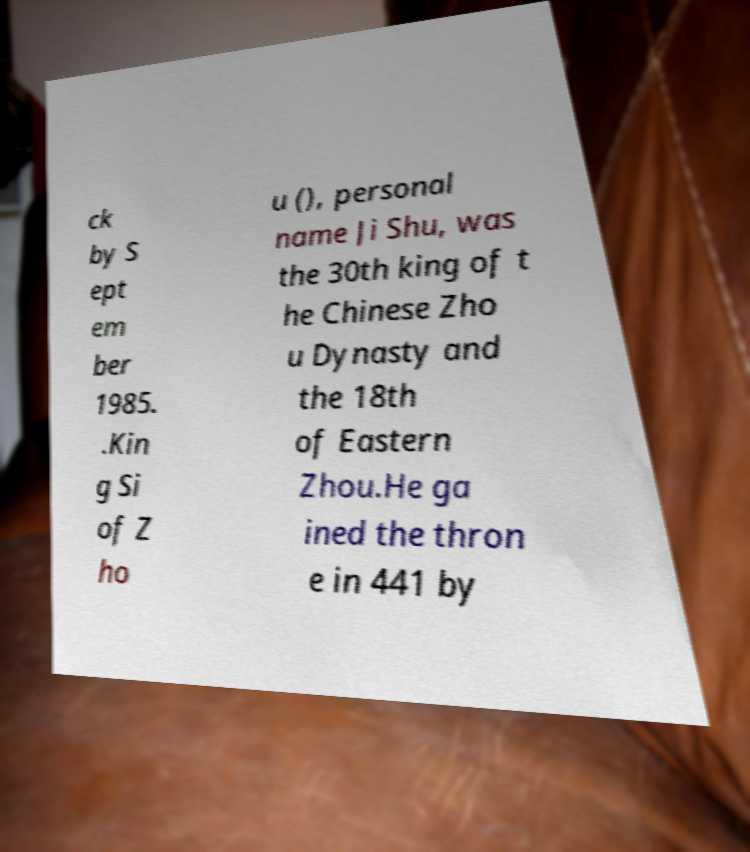Please read and relay the text visible in this image. What does it say? ck by S ept em ber 1985. .Kin g Si of Z ho u (), personal name Ji Shu, was the 30th king of t he Chinese Zho u Dynasty and the 18th of Eastern Zhou.He ga ined the thron e in 441 by 